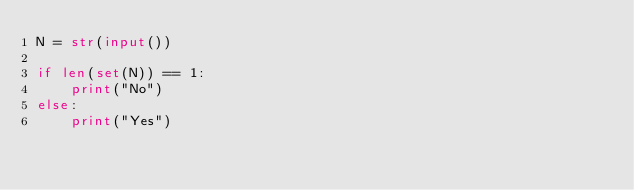Convert code to text. <code><loc_0><loc_0><loc_500><loc_500><_Python_>N = str(input())

if len(set(N)) == 1:
    print("No")
else:
    print("Yes")</code> 